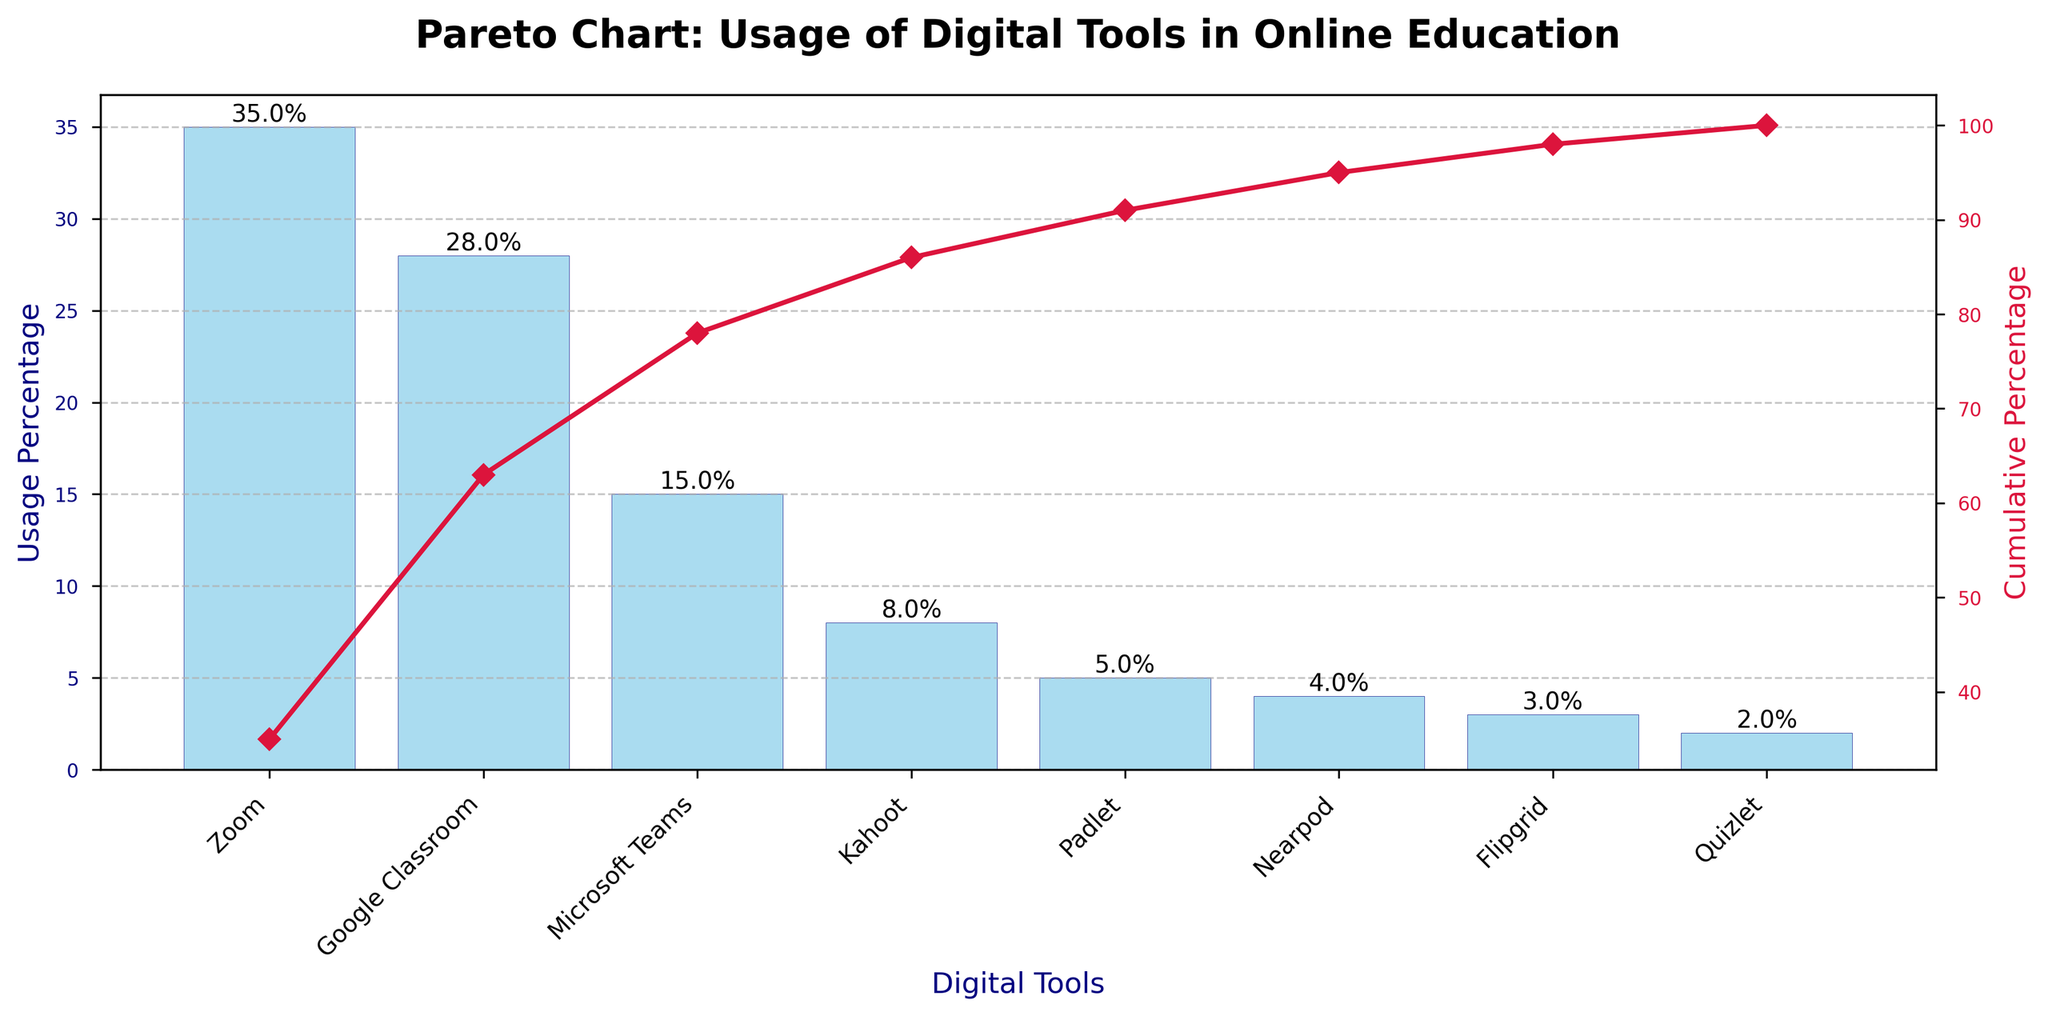What digital tool has the highest usage percentage? The digital tool with the highest bar in the figure has the highest usage percentage. This digital tool is Zoom.
Answer: Zoom What is the cumulative percentage for Google Classroom? To find the cumulative percentage, look at the cumulative percentage line where it intersects with Google Classroom. It's around 63%.
Answer: 63% How many digital tools have a usage percentage lower than 10%? Count the bars that represent digital tools with a usage percentage below 10%. There are five such tools: Kahoot, Padlet, Nearpod, Flipgrid, and Quizlet.
Answer: Five What is the difference in usage percentage between Zoom and Microsoft Teams? Subtract the usage percentage of Microsoft Teams (15%) from that of Zoom (35%). The difference is 35% - 15% = 20%.
Answer: 20% Which digital tool's usage causes the cumulative percentage to exceed 50%? Observe the cumulative percentage line and see which digital tool's bar causes the cumulative percentage to go past 50%. This happens at Google Classroom.
Answer: Google Classroom What percentage of tools together make up the top two tools based on usage percentage? Add the usage percentages of the top two tools, which are Zoom (35%) and Google Classroom (28%). The total is 35% + 28% = 63%.
Answer: 63% What is the cumulative percentage achieved by the usage of Zoom, Google Classroom, and Microsoft Teams combined? Add the usage percentages of Zoom (35%), Google Classroom (28%), and Microsoft Teams (15%), which gives 78%. The cumulative percentage at Microsoft Teams includes these three tools.
Answer: 78% Which tool has the lowest usage percentage and what is it? Find the shortest bar to identify the tool with the lowest usage percentage. This tool is Quizlet, with 2%.
Answer: Quizlet, 2% How does the cumulative percentage change from Nearpod to Flipgrid? Calculate the cumulative percentages at Nearpod (85%) and Flipgrid (89%). The change is 89% - 85% = 4%.
Answer: 4% Which tools together constitute the cumulative percentage just over 80%? Check the bars and their cumulative percentages to find which grouping gets slightly over 80%. Padlet is the tool that brings the cumulative percentage to near 80%; the tools are Zoom, Google Classroom, Microsoft Teams, Kahoot, and Padlet.
Answer: Zoom, Google Classroom, Microsoft Teams, Kahoot, Padlet 